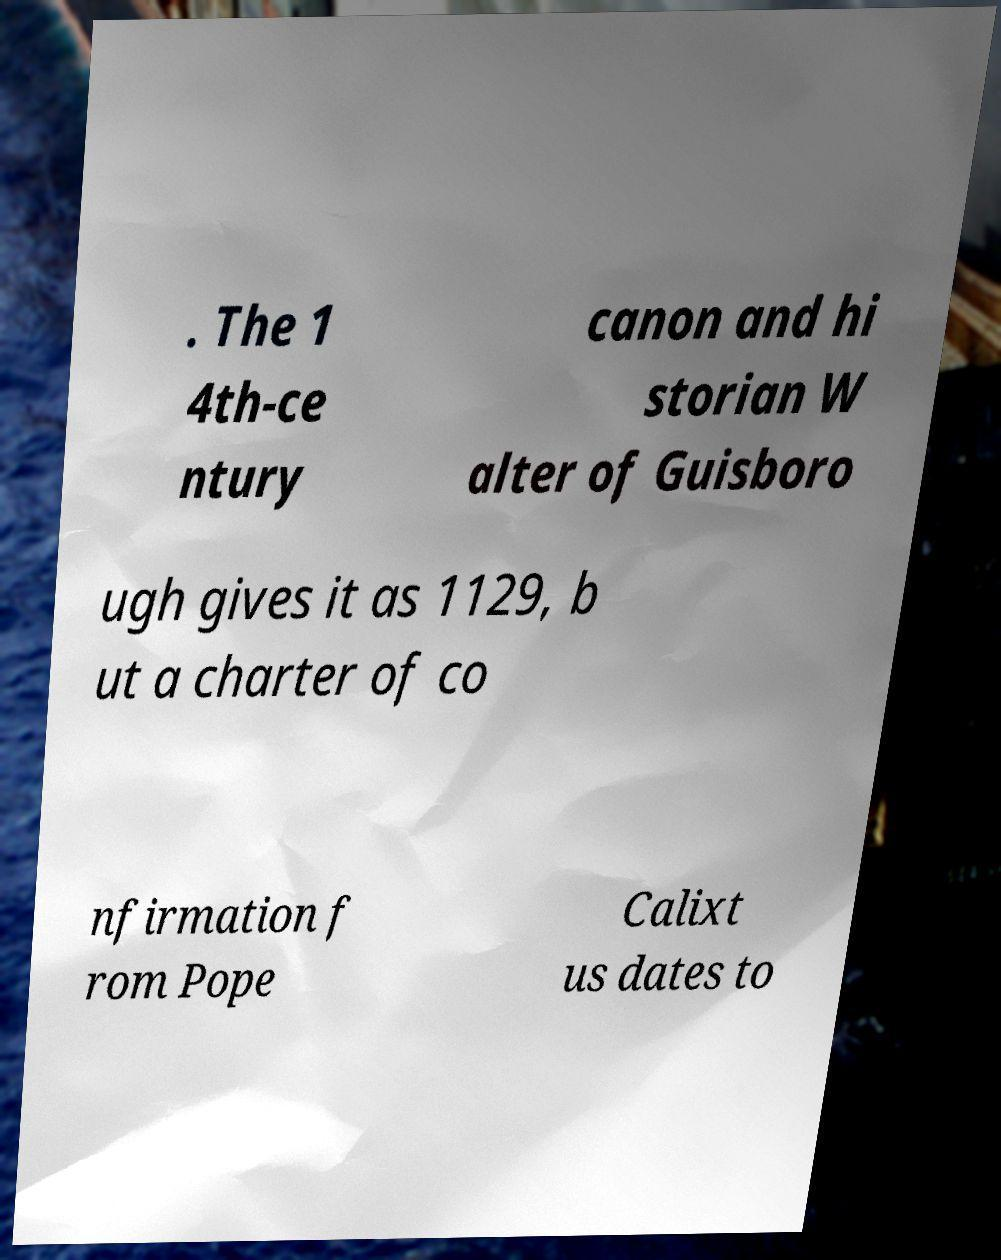There's text embedded in this image that I need extracted. Can you transcribe it verbatim? . The 1 4th-ce ntury canon and hi storian W alter of Guisboro ugh gives it as 1129, b ut a charter of co nfirmation f rom Pope Calixt us dates to 